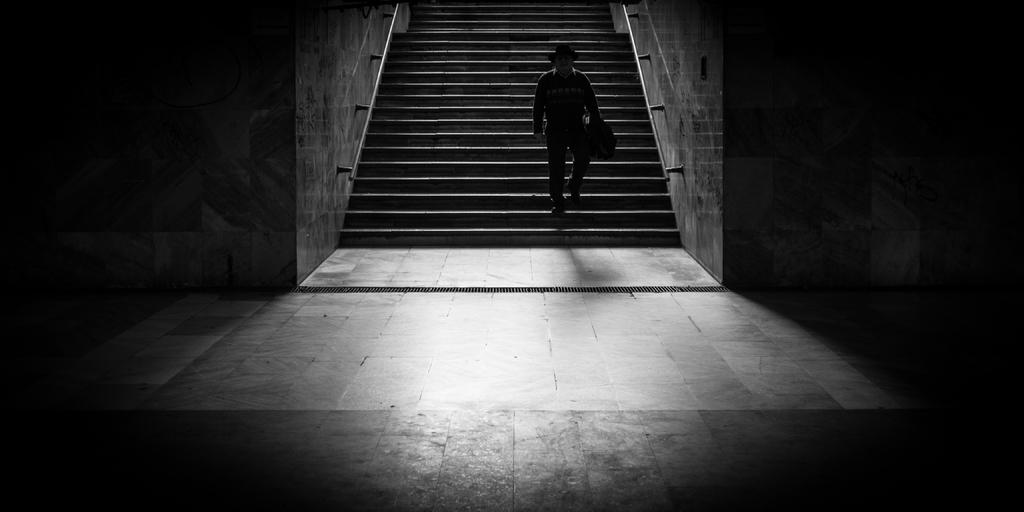Who or what is present in the image? There is a person in the image. What architectural feature can be seen in the image? There are steps in the image. What is the background of the image composed of? There is a wall in the image. What is the color scheme of the image? The image is black and white in color. How many apples are on the person's head in the image? There are no apples present in the image. What type of health advice can be seen on the wall in the image? There is no health advice visible on the wall in the image. 